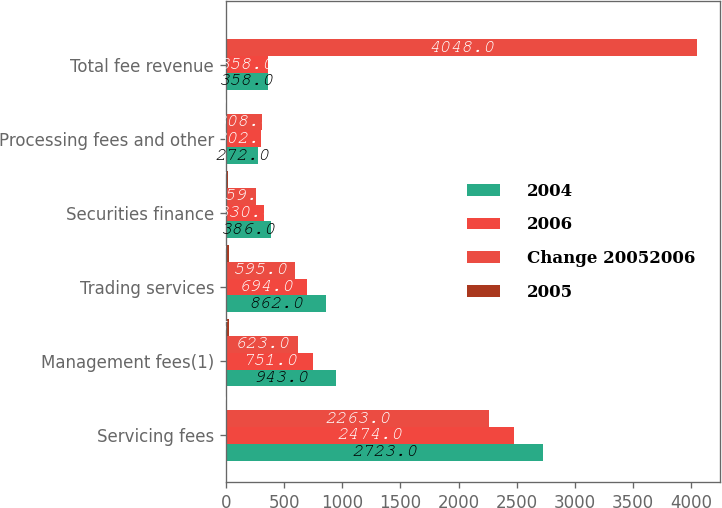Convert chart to OTSL. <chart><loc_0><loc_0><loc_500><loc_500><stacked_bar_chart><ecel><fcel>Servicing fees<fcel>Management fees(1)<fcel>Trading services<fcel>Securities finance<fcel>Processing fees and other<fcel>Total fee revenue<nl><fcel>2004<fcel>2723<fcel>943<fcel>862<fcel>386<fcel>272<fcel>358<nl><fcel>2006<fcel>2474<fcel>751<fcel>694<fcel>330<fcel>302<fcel>358<nl><fcel>Change 20052006<fcel>2263<fcel>623<fcel>595<fcel>259<fcel>308<fcel>4048<nl><fcel>2005<fcel>10<fcel>26<fcel>24<fcel>17<fcel>10<fcel>14<nl></chart> 